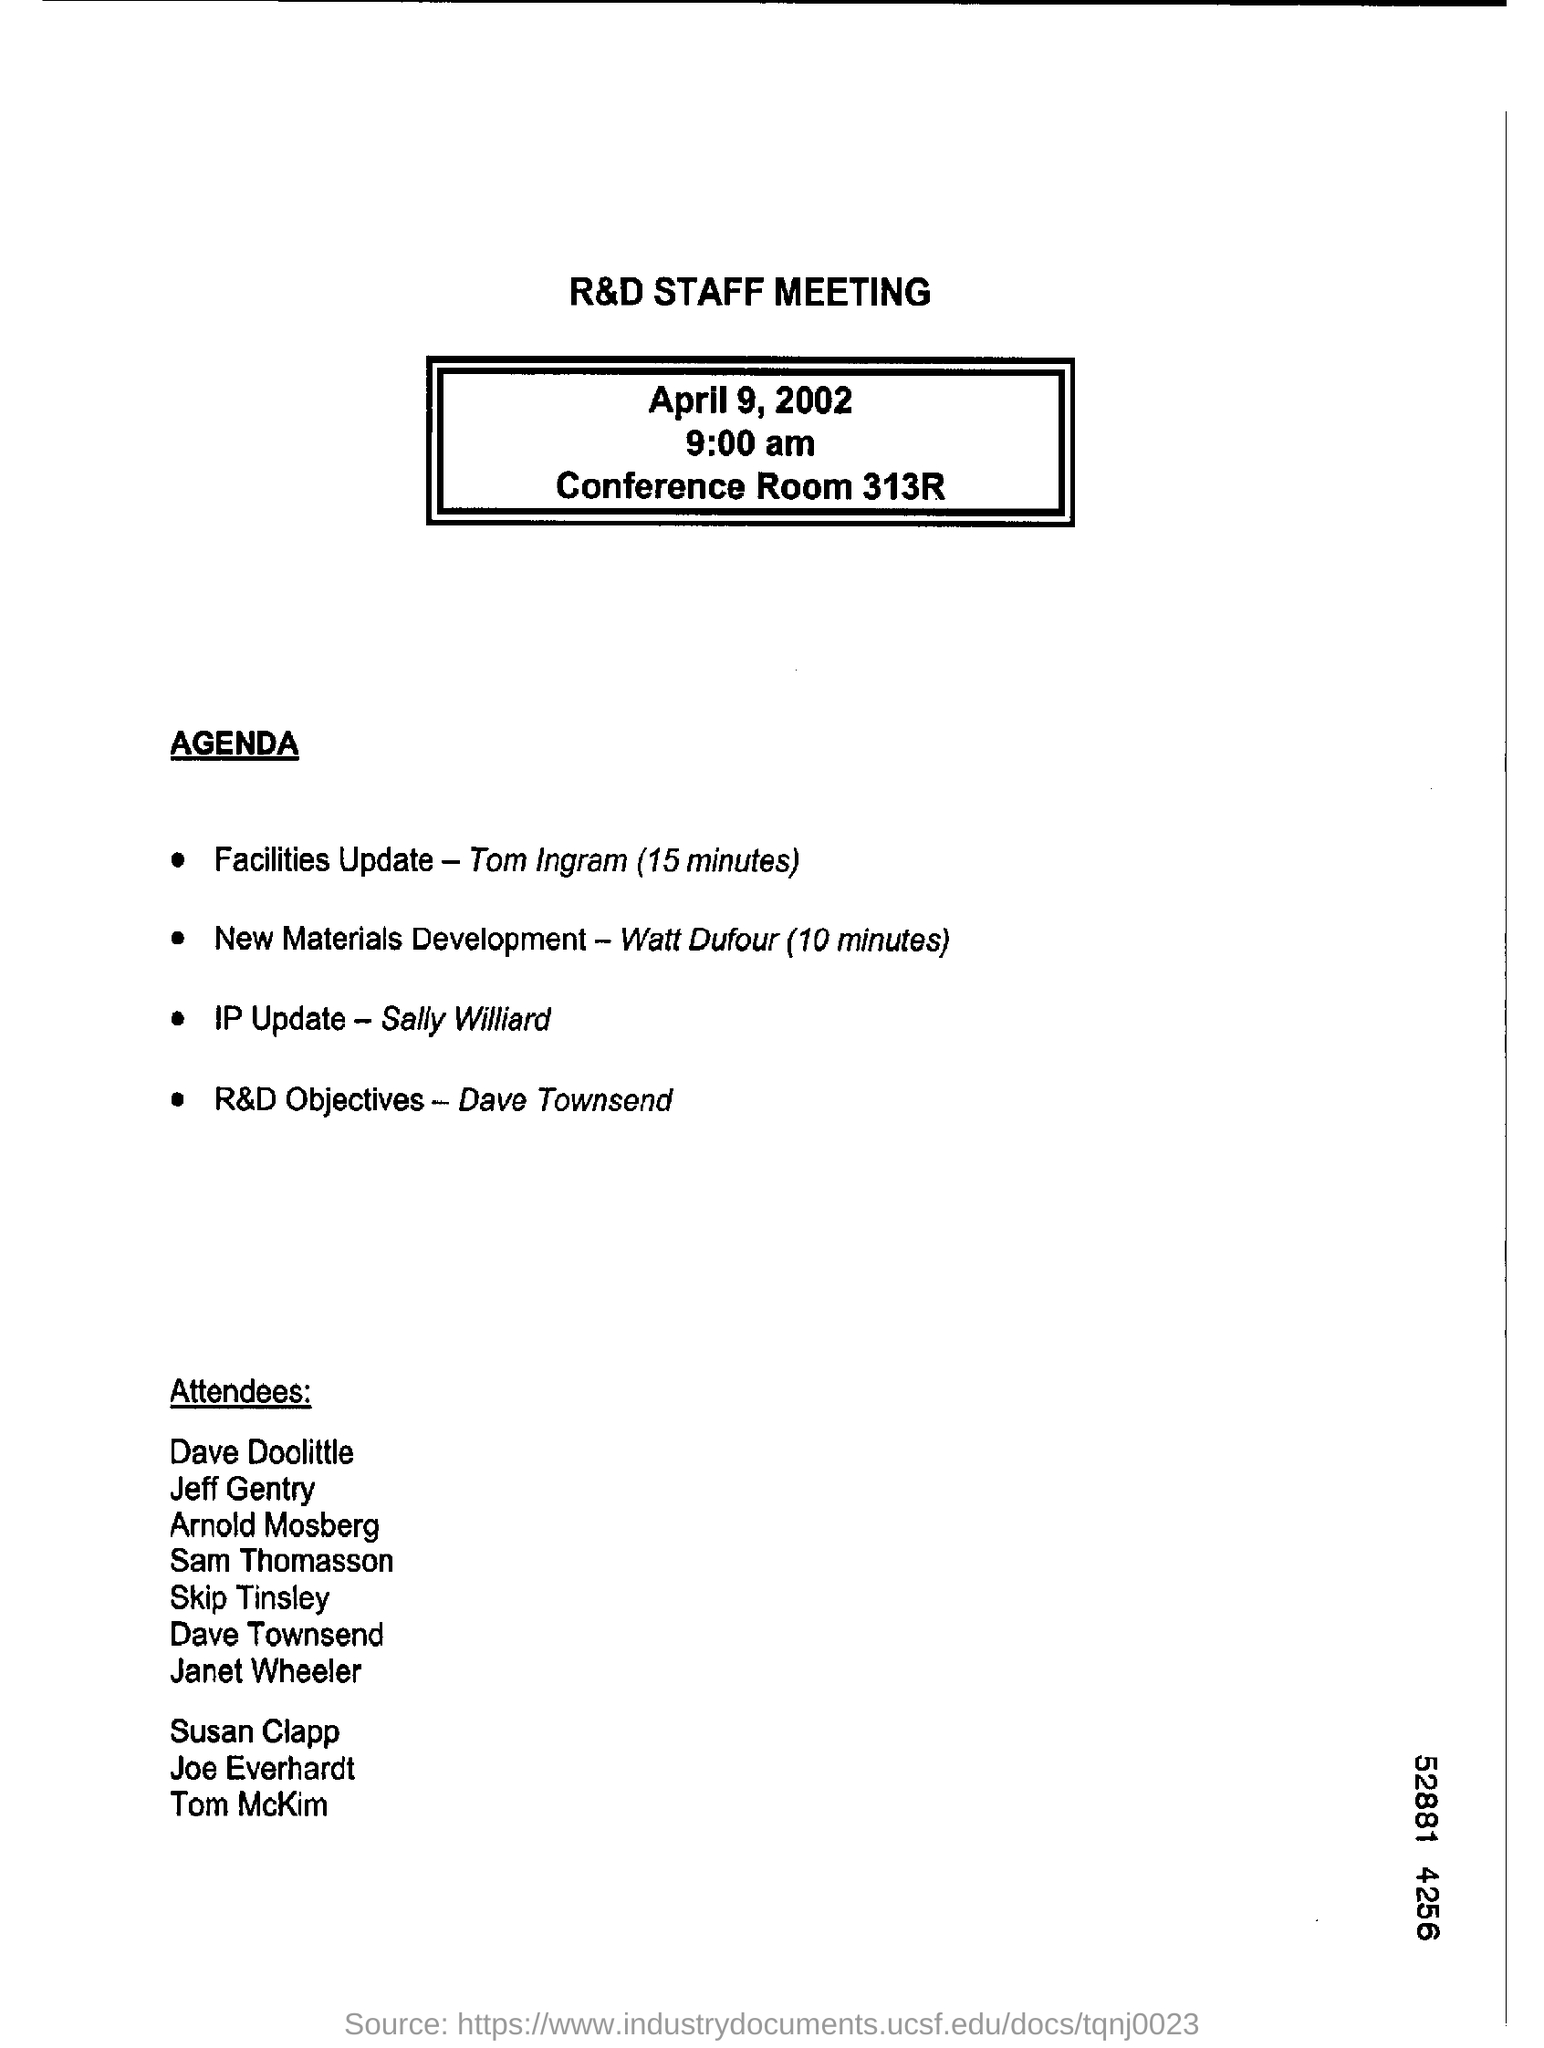Who will head IP update?
Your answer should be compact. Sally Williard. What is the topic of Dave Townsend?
Offer a terse response. R&D Objectives. On what date is the R&d Staff Meeting going to be held?
Make the answer very short. April 9, 2002. Where is the venue for the meeting?
Your answer should be compact. Conference Room 313R. At what time will the meeting start?
Offer a very short reply. 9:00 am. 